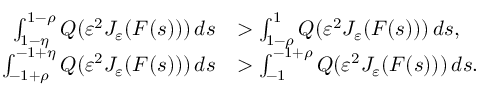Convert formula to latex. <formula><loc_0><loc_0><loc_500><loc_500>\begin{array} { r l } { \int _ { 1 - \eta } ^ { 1 - \rho } Q ( \varepsilon ^ { 2 } J _ { \varepsilon } ( F ( s ) ) ) \, d s } & { > \int _ { 1 - \rho } ^ { 1 } Q ( \varepsilon ^ { 2 } J _ { \varepsilon } ( F ( s ) ) ) \, d s , } \\ { \int _ { - 1 + \rho } ^ { - 1 + \eta } Q ( \varepsilon ^ { 2 } J _ { \varepsilon } ( F ( s ) ) ) \, d s } & { > \int _ { - 1 } ^ { - 1 + \rho } Q ( \varepsilon ^ { 2 } J _ { \varepsilon } ( F ( s ) ) ) \, d s . } \end{array}</formula> 